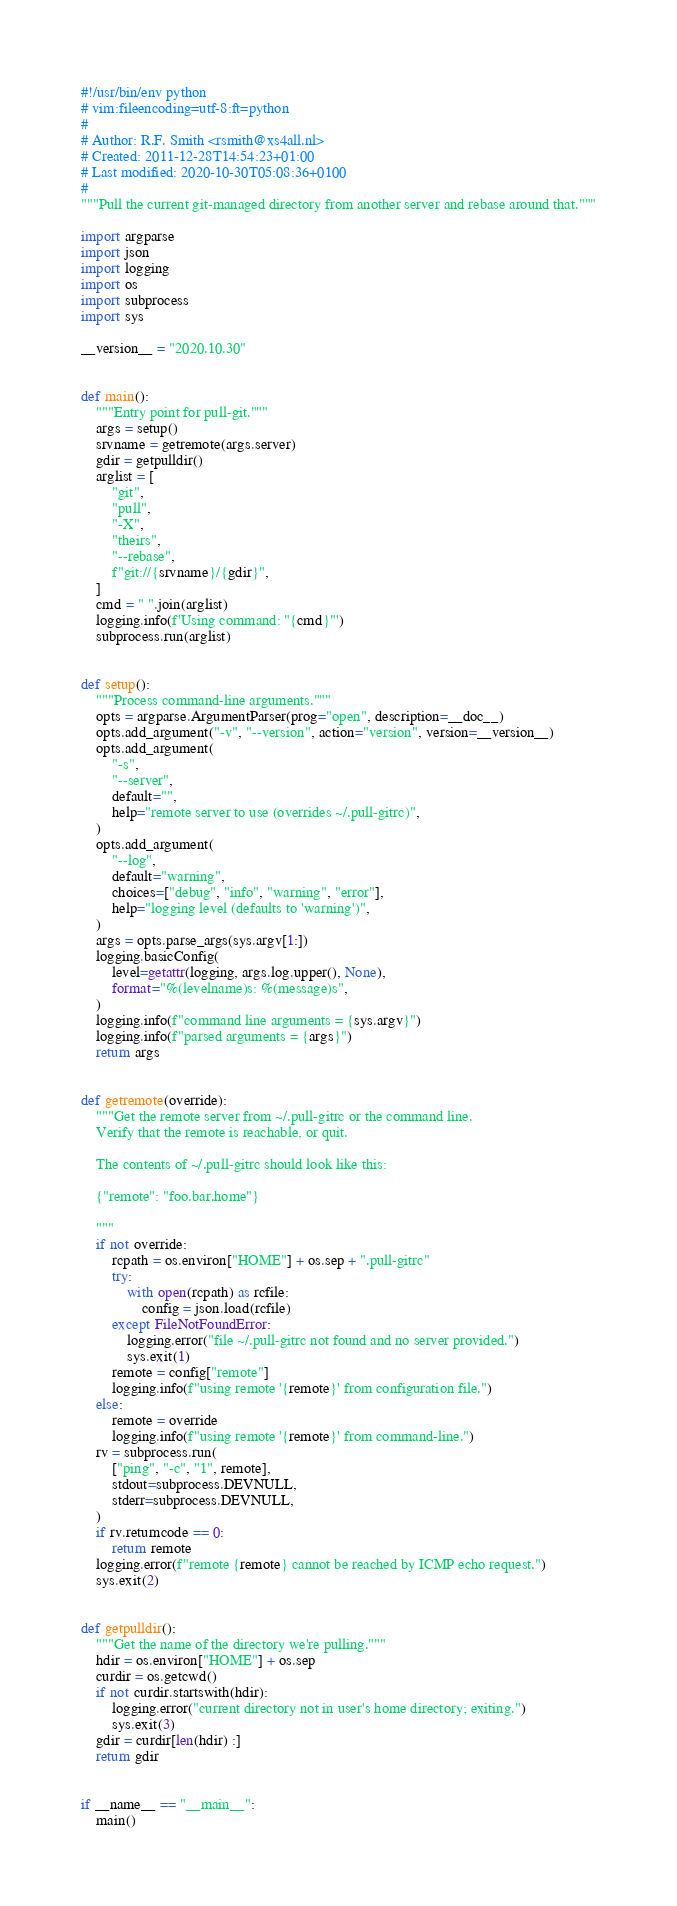Convert code to text. <code><loc_0><loc_0><loc_500><loc_500><_Python_>#!/usr/bin/env python
# vim:fileencoding=utf-8:ft=python
#
# Author: R.F. Smith <rsmith@xs4all.nl>
# Created: 2011-12-28T14:54:23+01:00
# Last modified: 2020-10-30T05:08:36+0100
#
"""Pull the current git-managed directory from another server and rebase around that."""

import argparse
import json
import logging
import os
import subprocess
import sys

__version__ = "2020.10.30"


def main():
    """Entry point for pull-git."""
    args = setup()
    srvname = getremote(args.server)
    gdir = getpulldir()
    arglist = [
        "git",
        "pull",
        "-X",
        "theirs",
        "--rebase",
        f"git://{srvname}/{gdir}",
    ]
    cmd = " ".join(arglist)
    logging.info(f'Using command: "{cmd}"')
    subprocess.run(arglist)


def setup():
    """Process command-line arguments."""
    opts = argparse.ArgumentParser(prog="open", description=__doc__)
    opts.add_argument("-v", "--version", action="version", version=__version__)
    opts.add_argument(
        "-s",
        "--server",
        default="",
        help="remote server to use (overrides ~/.pull-gitrc)",
    )
    opts.add_argument(
        "--log",
        default="warning",
        choices=["debug", "info", "warning", "error"],
        help="logging level (defaults to 'warning')",
    )
    args = opts.parse_args(sys.argv[1:])
    logging.basicConfig(
        level=getattr(logging, args.log.upper(), None),
        format="%(levelname)s: %(message)s",
    )
    logging.info(f"command line arguments = {sys.argv}")
    logging.info(f"parsed arguments = {args}")
    return args


def getremote(override):
    """Get the remote server from ~/.pull-gitrc or the command line.
    Verify that the remote is reachable, or quit.

    The contents of ~/.pull-gitrc should look like this:

    {"remote": "foo.bar.home"}

    """
    if not override:
        rcpath = os.environ["HOME"] + os.sep + ".pull-gitrc"
        try:
            with open(rcpath) as rcfile:
                config = json.load(rcfile)
        except FileNotFoundError:
            logging.error("file ~/.pull-gitrc not found and no server provided.")
            sys.exit(1)
        remote = config["remote"]
        logging.info(f"using remote '{remote}' from configuration file.")
    else:
        remote = override
        logging.info(f"using remote '{remote}' from command-line.")
    rv = subprocess.run(
        ["ping", "-c", "1", remote],
        stdout=subprocess.DEVNULL,
        stderr=subprocess.DEVNULL,
    )
    if rv.returncode == 0:
        return remote
    logging.error(f"remote {remote} cannot be reached by ICMP echo request.")
    sys.exit(2)


def getpulldir():
    """Get the name of the directory we're pulling."""
    hdir = os.environ["HOME"] + os.sep
    curdir = os.getcwd()
    if not curdir.startswith(hdir):
        logging.error("current directory not in user's home directory; exiting.")
        sys.exit(3)
    gdir = curdir[len(hdir) :]
    return gdir


if __name__ == "__main__":
    main()
</code> 